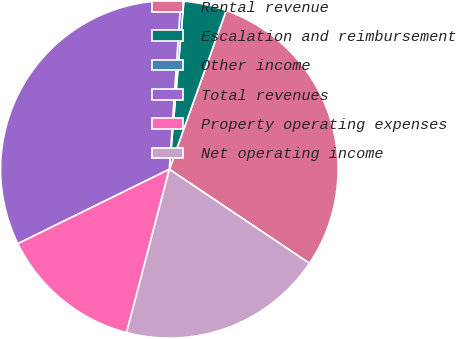Convert chart. <chart><loc_0><loc_0><loc_500><loc_500><pie_chart><fcel>Rental revenue<fcel>Escalation and reimbursement<fcel>Other income<fcel>Total revenues<fcel>Property operating expenses<fcel>Net operating income<nl><fcel>28.94%<fcel>4.1%<fcel>0.29%<fcel>33.34%<fcel>13.66%<fcel>19.67%<nl></chart> 